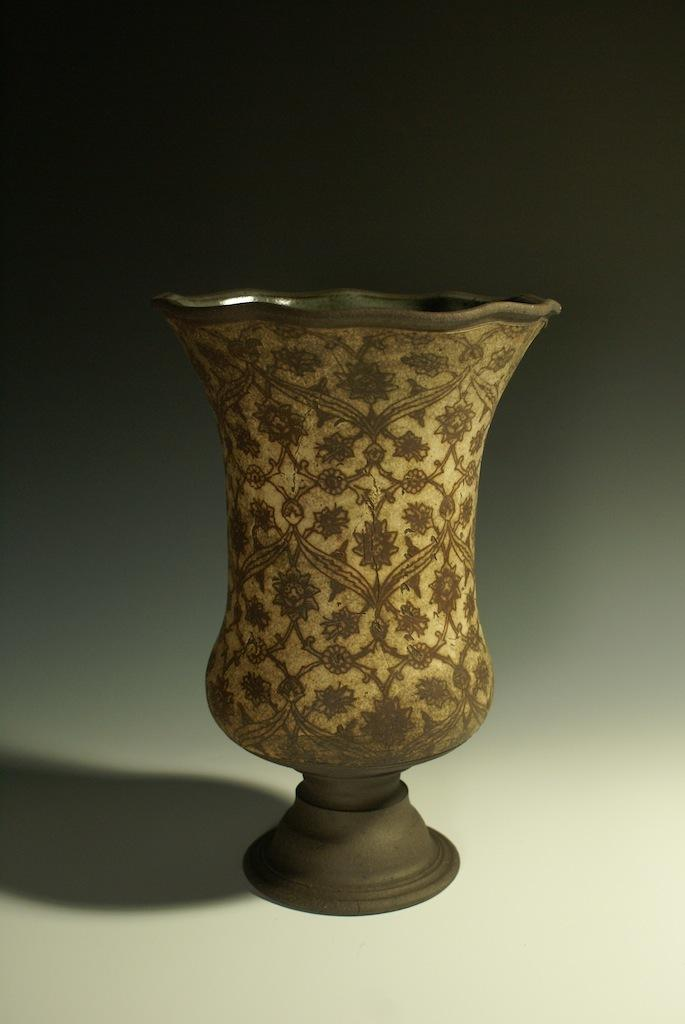What object can be seen in the image that is typically used for holding flowers? There is a flower vase in the image. What material is the flower vase made of? The flower vase is made of ceramic. Where is the flower vase located in the image? The flower vase is on the floor. What is the color of the floor in the image? The floor is white in color. What is the color of the flower vase in the image? The flower vase is brown in color. How does the flower vase express regret in the image? The flower vase does not express regret in the image, as it is an inanimate object and cannot experience emotions like regret. 